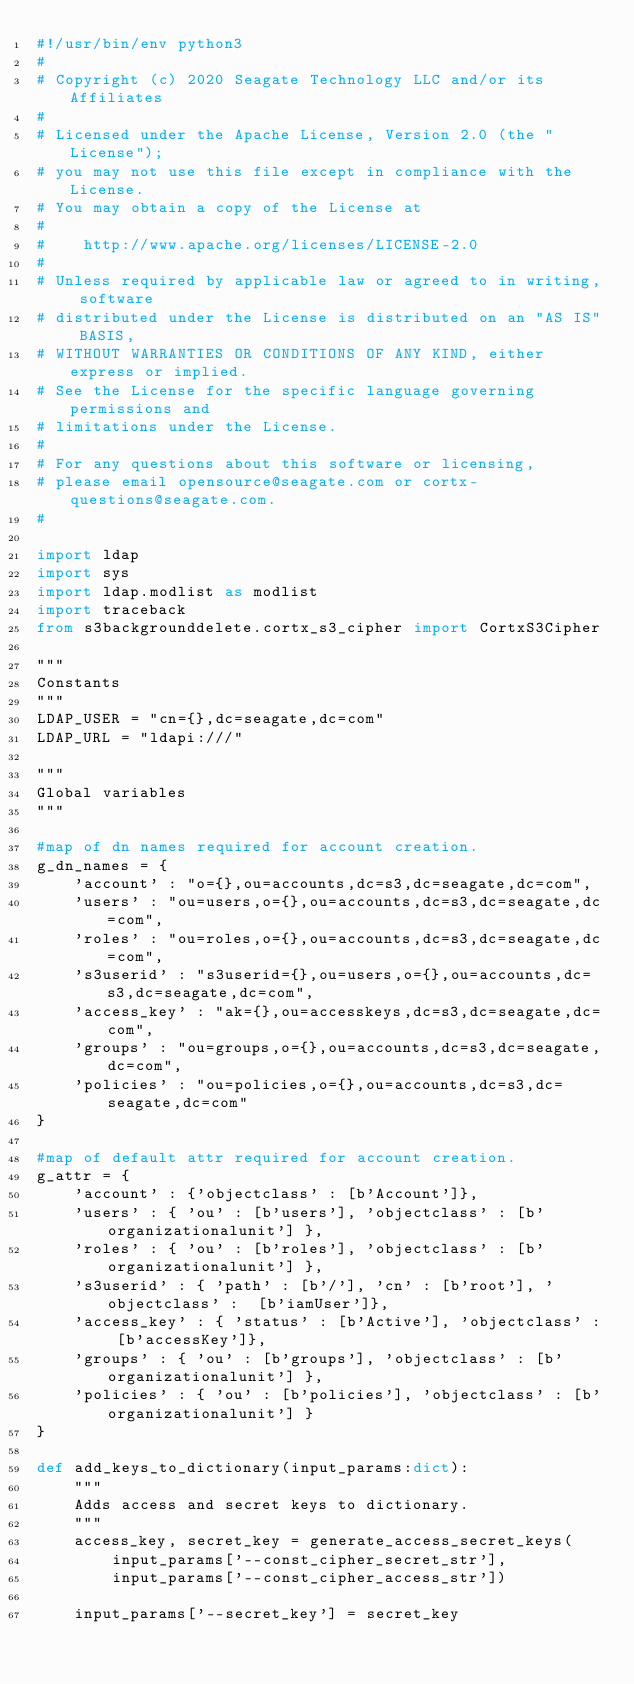<code> <loc_0><loc_0><loc_500><loc_500><_Python_>#!/usr/bin/env python3
#
# Copyright (c) 2020 Seagate Technology LLC and/or its Affiliates
#
# Licensed under the Apache License, Version 2.0 (the "License");
# you may not use this file except in compliance with the License.
# You may obtain a copy of the License at
#
#    http://www.apache.org/licenses/LICENSE-2.0
#
# Unless required by applicable law or agreed to in writing, software
# distributed under the License is distributed on an "AS IS" BASIS,
# WITHOUT WARRANTIES OR CONDITIONS OF ANY KIND, either express or implied.
# See the License for the specific language governing permissions and
# limitations under the License.
#
# For any questions about this software or licensing,
# please email opensource@seagate.com or cortx-questions@seagate.com.
#

import ldap
import sys
import ldap.modlist as modlist
import traceback
from s3backgrounddelete.cortx_s3_cipher import CortxS3Cipher

"""
Constants
"""
LDAP_USER = "cn={},dc=seagate,dc=com"
LDAP_URL = "ldapi:///"

"""
Global variables
"""

#map of dn names required for account creation.
g_dn_names = {
    'account' : "o={},ou=accounts,dc=s3,dc=seagate,dc=com",
    'users' : "ou=users,o={},ou=accounts,dc=s3,dc=seagate,dc=com",
    'roles' : "ou=roles,o={},ou=accounts,dc=s3,dc=seagate,dc=com",
    's3userid' : "s3userid={},ou=users,o={},ou=accounts,dc=s3,dc=seagate,dc=com",
    'access_key' : "ak={},ou=accesskeys,dc=s3,dc=seagate,dc=com",
    'groups' : "ou=groups,o={},ou=accounts,dc=s3,dc=seagate,dc=com",
    'policies' : "ou=policies,o={},ou=accounts,dc=s3,dc=seagate,dc=com"
}

#map of default attr required for account creation.
g_attr = {
    'account' : {'objectclass' : [b'Account']},
    'users' : { 'ou' : [b'users'], 'objectclass' : [b'organizationalunit'] },
    'roles' : { 'ou' : [b'roles'], 'objectclass' : [b'organizationalunit'] },
    's3userid' : { 'path' : [b'/'], 'cn' : [b'root'], 'objectclass' :  [b'iamUser']},
    'access_key' : { 'status' : [b'Active'], 'objectclass' : [b'accessKey']},
    'groups' : { 'ou' : [b'groups'], 'objectclass' : [b'organizationalunit'] },
    'policies' : { 'ou' : [b'policies'], 'objectclass' : [b'organizationalunit'] }
}

def add_keys_to_dictionary(input_params:dict):
    """
    Adds access and secret keys to dictionary.
    """
    access_key, secret_key = generate_access_secret_keys(
        input_params['--const_cipher_secret_str'],
        input_params['--const_cipher_access_str'])
    
    input_params['--secret_key'] = secret_key</code> 